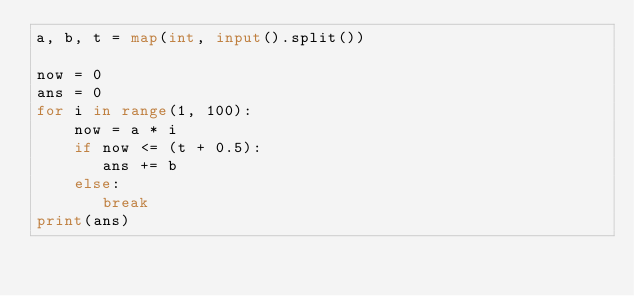<code> <loc_0><loc_0><loc_500><loc_500><_Python_>a, b, t = map(int, input().split())

now = 0
ans = 0
for i in range(1, 100):
    now = a * i
    if now <= (t + 0.5):
       ans += b
    else:
       break
print(ans)</code> 